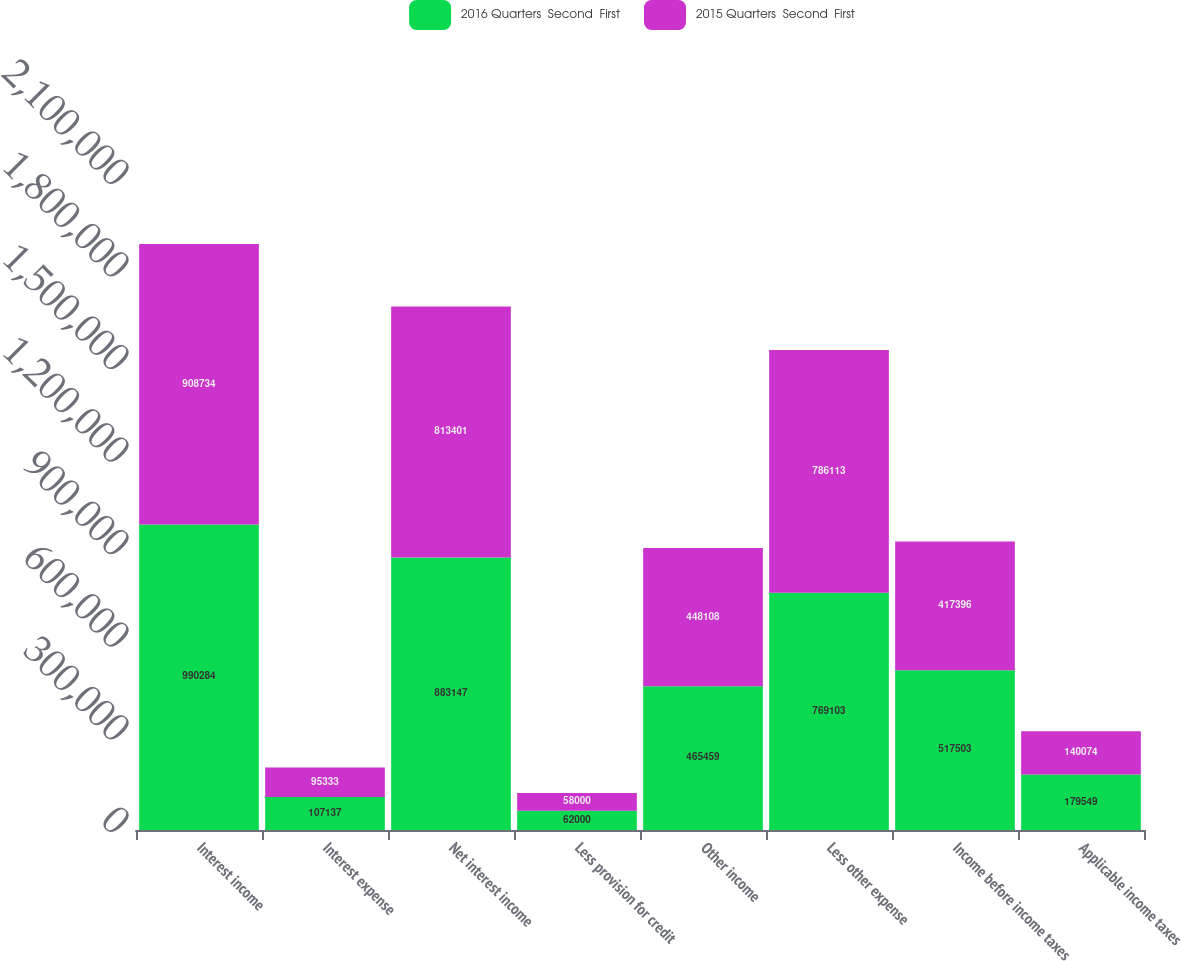Convert chart. <chart><loc_0><loc_0><loc_500><loc_500><stacked_bar_chart><ecel><fcel>Interest income<fcel>Interest expense<fcel>Net interest income<fcel>Less provision for credit<fcel>Other income<fcel>Less other expense<fcel>Income before income taxes<fcel>Applicable income taxes<nl><fcel>2016 Quarters  Second  First<fcel>990284<fcel>107137<fcel>883147<fcel>62000<fcel>465459<fcel>769103<fcel>517503<fcel>179549<nl><fcel>2015 Quarters  Second  First<fcel>908734<fcel>95333<fcel>813401<fcel>58000<fcel>448108<fcel>786113<fcel>417396<fcel>140074<nl></chart> 